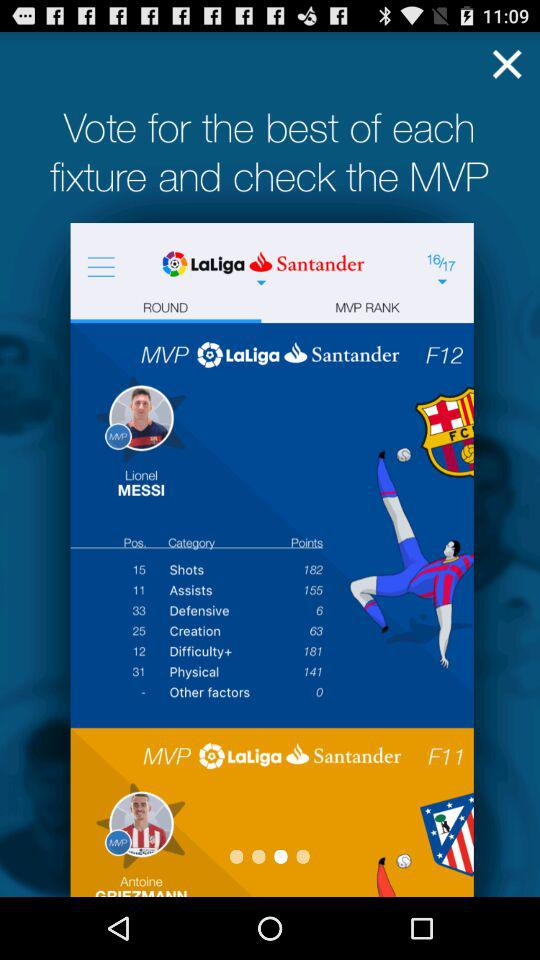Which tab is selected? The selected tab is "ROUND". 